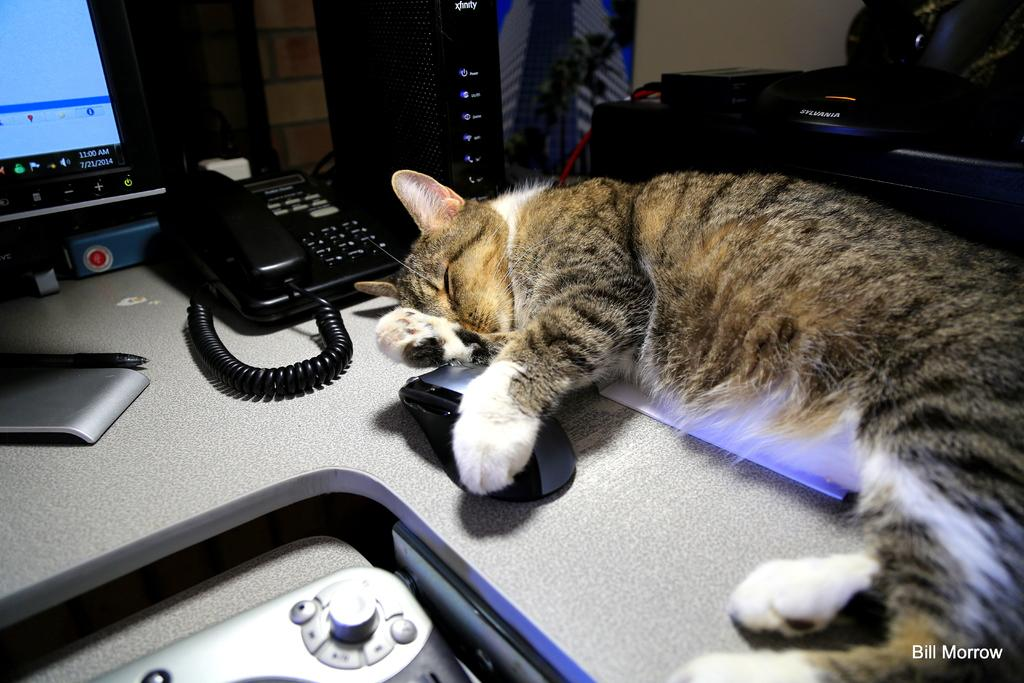What type of animal can be seen in the image? There is a cat in the image. What piece of furniture is present in the image? There is a table in the image. What electronic devices are on the table? A monitor, a CPU, and a mouse are on the table. What writing instrument is on the table? A pen is on the table. What other objects can be seen on the table? There are other objects on the table, but their specific details are not mentioned in the facts. What is visible behind the table in the image? There is a wall visible in the image. What type of winter game is being played in the image? There is no winter game present in the image; it features a cat, a table, electronic devices, and other objects. 